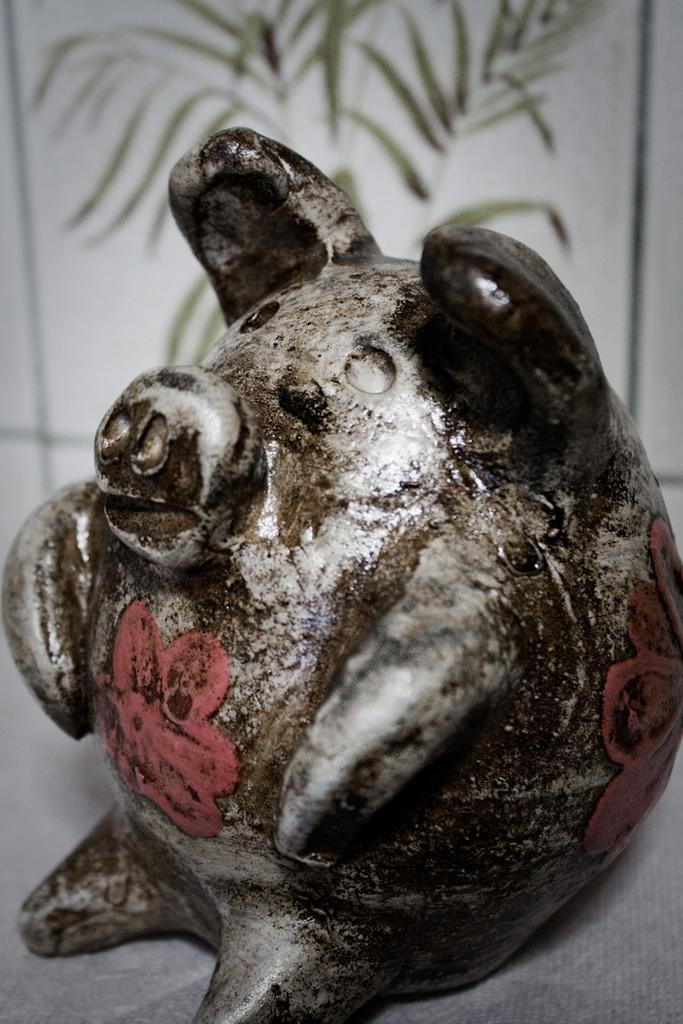What is the main subject in the image? There is a sculpture in the image. Can you describe the background of the image? The background of the image is blurred. What type of gate can be seen in the image? There is no gate present in the image; it features a sculpture with a blurred background. How many shoes are visible in the image? There are no shoes visible in the image. 